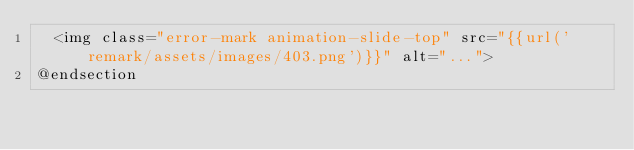Convert code to text. <code><loc_0><loc_0><loc_500><loc_500><_PHP_>  <img class="error-mark animation-slide-top" src="{{url('remark/assets/images/403.png')}}" alt="...">
@endsection</code> 